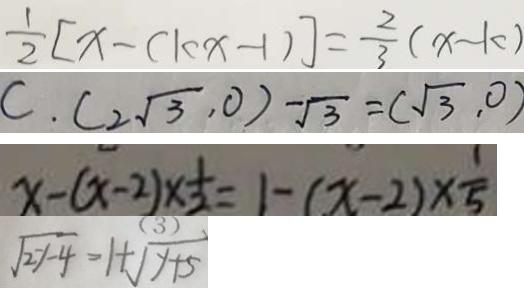Convert formula to latex. <formula><loc_0><loc_0><loc_500><loc_500>\frac { 1 } { 2 } [ x - ( c k x - 1 ) ] = \frac { 2 } { 3 } ( x - k ) 
 C . ( 2 \sqrt { 3 } , 0 ) - \sqrt { 3 } = ( \sqrt { 3 } , 0 ) 
 x - ( x - 2 ) \times \frac { 1 } { 2 } = 1 - ( x - 2 ) \times \frac { 1 } { 5 } 
 \sqrt { 2 y - 4 } = 1 + \sqrt { y + 5 }</formula> 